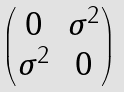<formula> <loc_0><loc_0><loc_500><loc_500>\begin{pmatrix} 0 & \sigma ^ { 2 } \\ \sigma ^ { 2 } & 0 \end{pmatrix}</formula> 